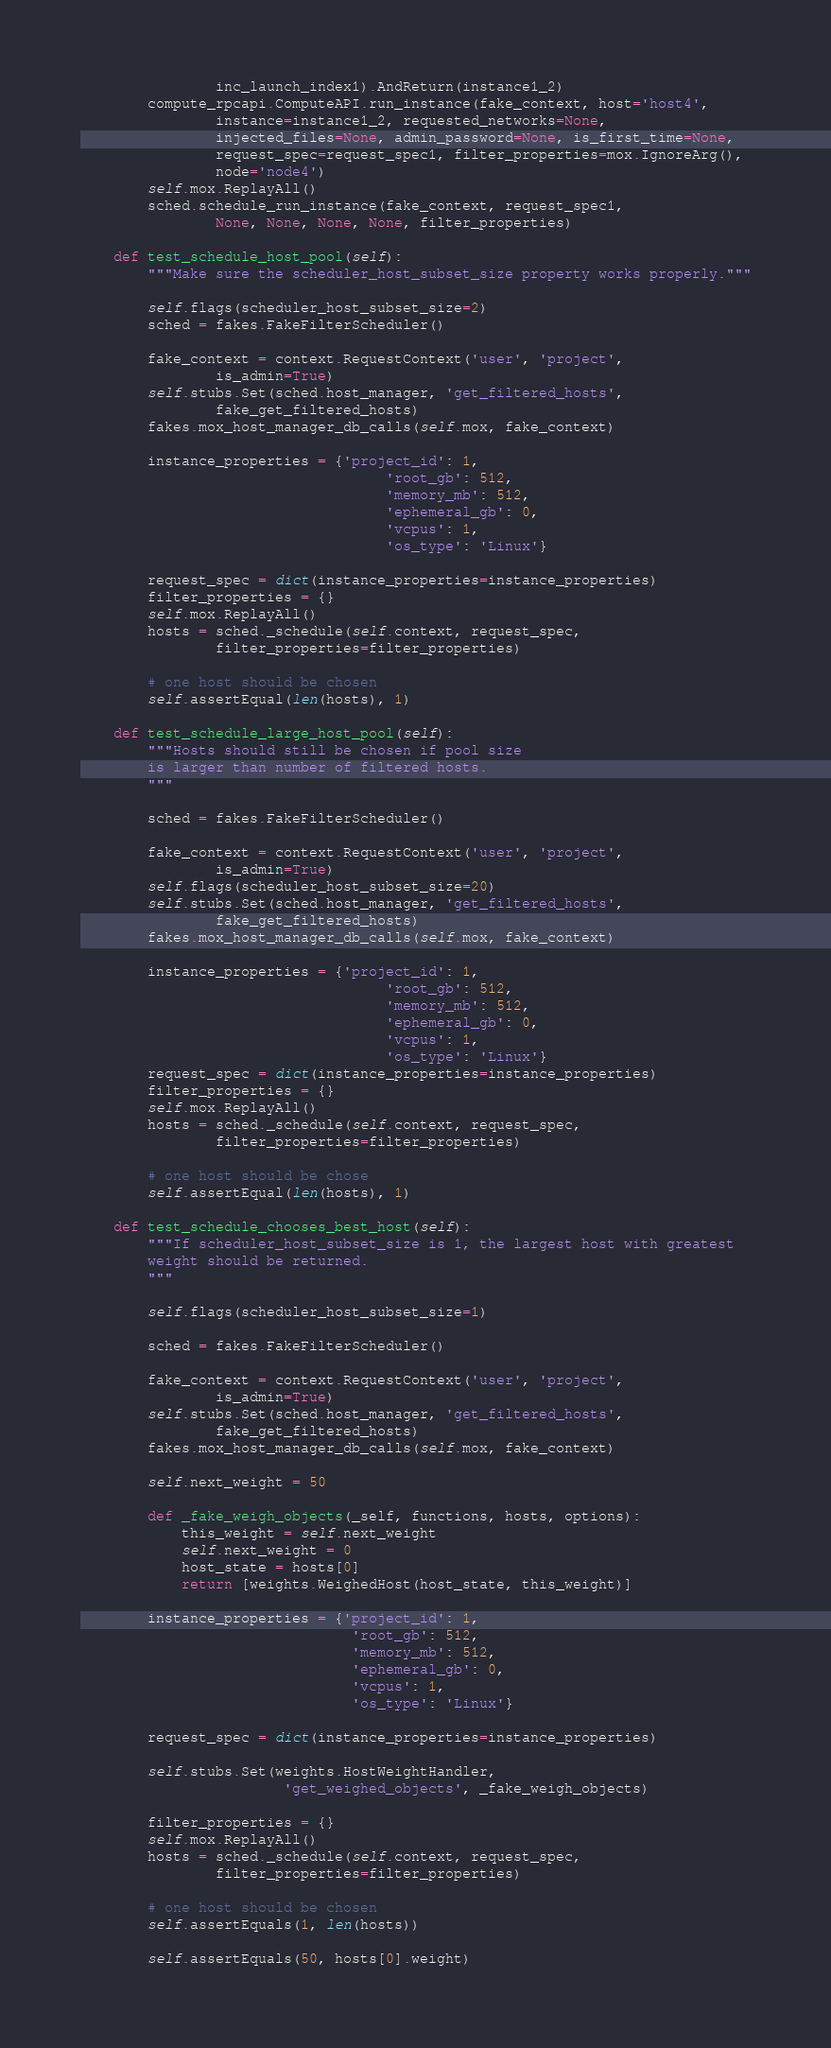<code> <loc_0><loc_0><loc_500><loc_500><_Python_>                inc_launch_index1).AndReturn(instance1_2)
        compute_rpcapi.ComputeAPI.run_instance(fake_context, host='host4',
                instance=instance1_2, requested_networks=None,
                injected_files=None, admin_password=None, is_first_time=None,
                request_spec=request_spec1, filter_properties=mox.IgnoreArg(),
                node='node4')
        self.mox.ReplayAll()
        sched.schedule_run_instance(fake_context, request_spec1,
                None, None, None, None, filter_properties)

    def test_schedule_host_pool(self):
        """Make sure the scheduler_host_subset_size property works properly."""

        self.flags(scheduler_host_subset_size=2)
        sched = fakes.FakeFilterScheduler()

        fake_context = context.RequestContext('user', 'project',
                is_admin=True)
        self.stubs.Set(sched.host_manager, 'get_filtered_hosts',
                fake_get_filtered_hosts)
        fakes.mox_host_manager_db_calls(self.mox, fake_context)

        instance_properties = {'project_id': 1,
                                    'root_gb': 512,
                                    'memory_mb': 512,
                                    'ephemeral_gb': 0,
                                    'vcpus': 1,
                                    'os_type': 'Linux'}

        request_spec = dict(instance_properties=instance_properties)
        filter_properties = {}
        self.mox.ReplayAll()
        hosts = sched._schedule(self.context, request_spec,
                filter_properties=filter_properties)

        # one host should be chosen
        self.assertEqual(len(hosts), 1)

    def test_schedule_large_host_pool(self):
        """Hosts should still be chosen if pool size
        is larger than number of filtered hosts.
        """

        sched = fakes.FakeFilterScheduler()

        fake_context = context.RequestContext('user', 'project',
                is_admin=True)
        self.flags(scheduler_host_subset_size=20)
        self.stubs.Set(sched.host_manager, 'get_filtered_hosts',
                fake_get_filtered_hosts)
        fakes.mox_host_manager_db_calls(self.mox, fake_context)

        instance_properties = {'project_id': 1,
                                    'root_gb': 512,
                                    'memory_mb': 512,
                                    'ephemeral_gb': 0,
                                    'vcpus': 1,
                                    'os_type': 'Linux'}
        request_spec = dict(instance_properties=instance_properties)
        filter_properties = {}
        self.mox.ReplayAll()
        hosts = sched._schedule(self.context, request_spec,
                filter_properties=filter_properties)

        # one host should be chose
        self.assertEqual(len(hosts), 1)

    def test_schedule_chooses_best_host(self):
        """If scheduler_host_subset_size is 1, the largest host with greatest
        weight should be returned.
        """

        self.flags(scheduler_host_subset_size=1)

        sched = fakes.FakeFilterScheduler()

        fake_context = context.RequestContext('user', 'project',
                is_admin=True)
        self.stubs.Set(sched.host_manager, 'get_filtered_hosts',
                fake_get_filtered_hosts)
        fakes.mox_host_manager_db_calls(self.mox, fake_context)

        self.next_weight = 50

        def _fake_weigh_objects(_self, functions, hosts, options):
            this_weight = self.next_weight
            self.next_weight = 0
            host_state = hosts[0]
            return [weights.WeighedHost(host_state, this_weight)]

        instance_properties = {'project_id': 1,
                                'root_gb': 512,
                                'memory_mb': 512,
                                'ephemeral_gb': 0,
                                'vcpus': 1,
                                'os_type': 'Linux'}

        request_spec = dict(instance_properties=instance_properties)

        self.stubs.Set(weights.HostWeightHandler,
                        'get_weighed_objects', _fake_weigh_objects)

        filter_properties = {}
        self.mox.ReplayAll()
        hosts = sched._schedule(self.context, request_spec,
                filter_properties=filter_properties)

        # one host should be chosen
        self.assertEquals(1, len(hosts))

        self.assertEquals(50, hosts[0].weight)
</code> 